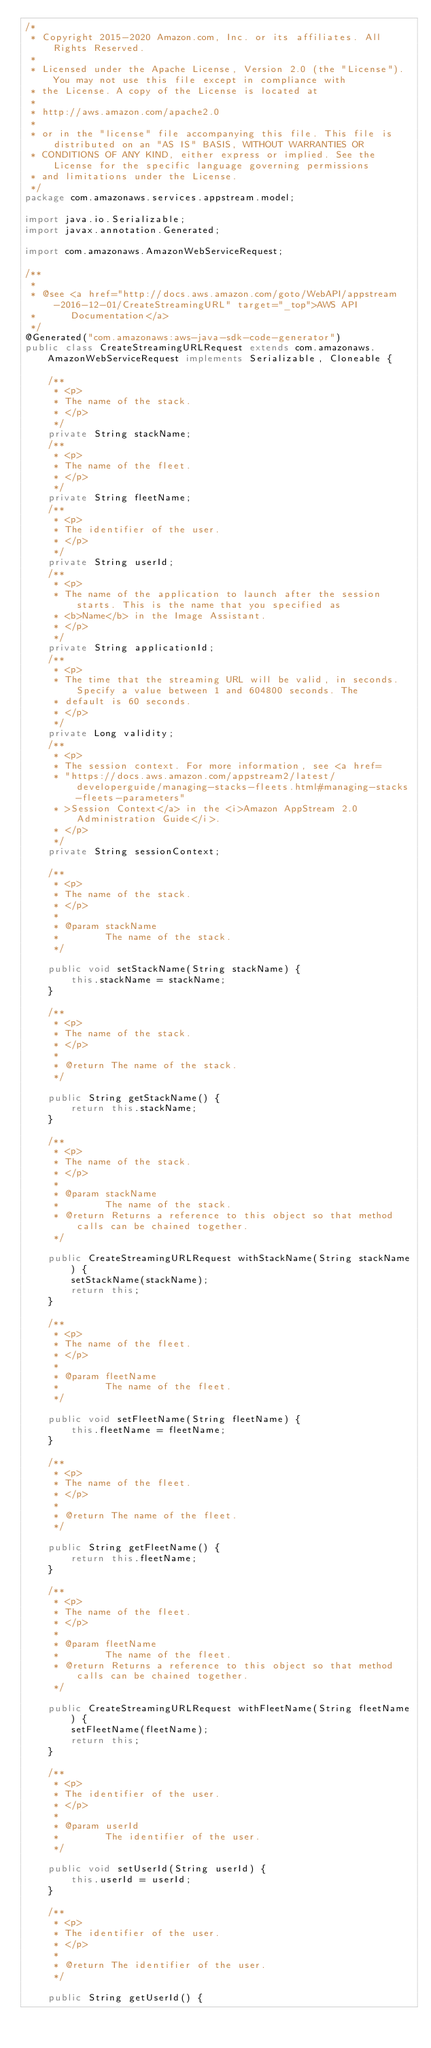<code> <loc_0><loc_0><loc_500><loc_500><_Java_>/*
 * Copyright 2015-2020 Amazon.com, Inc. or its affiliates. All Rights Reserved.
 * 
 * Licensed under the Apache License, Version 2.0 (the "License"). You may not use this file except in compliance with
 * the License. A copy of the License is located at
 * 
 * http://aws.amazon.com/apache2.0
 * 
 * or in the "license" file accompanying this file. This file is distributed on an "AS IS" BASIS, WITHOUT WARRANTIES OR
 * CONDITIONS OF ANY KIND, either express or implied. See the License for the specific language governing permissions
 * and limitations under the License.
 */
package com.amazonaws.services.appstream.model;

import java.io.Serializable;
import javax.annotation.Generated;

import com.amazonaws.AmazonWebServiceRequest;

/**
 * 
 * @see <a href="http://docs.aws.amazon.com/goto/WebAPI/appstream-2016-12-01/CreateStreamingURL" target="_top">AWS API
 *      Documentation</a>
 */
@Generated("com.amazonaws:aws-java-sdk-code-generator")
public class CreateStreamingURLRequest extends com.amazonaws.AmazonWebServiceRequest implements Serializable, Cloneable {

    /**
     * <p>
     * The name of the stack.
     * </p>
     */
    private String stackName;
    /**
     * <p>
     * The name of the fleet.
     * </p>
     */
    private String fleetName;
    /**
     * <p>
     * The identifier of the user.
     * </p>
     */
    private String userId;
    /**
     * <p>
     * The name of the application to launch after the session starts. This is the name that you specified as
     * <b>Name</b> in the Image Assistant.
     * </p>
     */
    private String applicationId;
    /**
     * <p>
     * The time that the streaming URL will be valid, in seconds. Specify a value between 1 and 604800 seconds. The
     * default is 60 seconds.
     * </p>
     */
    private Long validity;
    /**
     * <p>
     * The session context. For more information, see <a href=
     * "https://docs.aws.amazon.com/appstream2/latest/developerguide/managing-stacks-fleets.html#managing-stacks-fleets-parameters"
     * >Session Context</a> in the <i>Amazon AppStream 2.0 Administration Guide</i>.
     * </p>
     */
    private String sessionContext;

    /**
     * <p>
     * The name of the stack.
     * </p>
     * 
     * @param stackName
     *        The name of the stack.
     */

    public void setStackName(String stackName) {
        this.stackName = stackName;
    }

    /**
     * <p>
     * The name of the stack.
     * </p>
     * 
     * @return The name of the stack.
     */

    public String getStackName() {
        return this.stackName;
    }

    /**
     * <p>
     * The name of the stack.
     * </p>
     * 
     * @param stackName
     *        The name of the stack.
     * @return Returns a reference to this object so that method calls can be chained together.
     */

    public CreateStreamingURLRequest withStackName(String stackName) {
        setStackName(stackName);
        return this;
    }

    /**
     * <p>
     * The name of the fleet.
     * </p>
     * 
     * @param fleetName
     *        The name of the fleet.
     */

    public void setFleetName(String fleetName) {
        this.fleetName = fleetName;
    }

    /**
     * <p>
     * The name of the fleet.
     * </p>
     * 
     * @return The name of the fleet.
     */

    public String getFleetName() {
        return this.fleetName;
    }

    /**
     * <p>
     * The name of the fleet.
     * </p>
     * 
     * @param fleetName
     *        The name of the fleet.
     * @return Returns a reference to this object so that method calls can be chained together.
     */

    public CreateStreamingURLRequest withFleetName(String fleetName) {
        setFleetName(fleetName);
        return this;
    }

    /**
     * <p>
     * The identifier of the user.
     * </p>
     * 
     * @param userId
     *        The identifier of the user.
     */

    public void setUserId(String userId) {
        this.userId = userId;
    }

    /**
     * <p>
     * The identifier of the user.
     * </p>
     * 
     * @return The identifier of the user.
     */

    public String getUserId() {</code> 